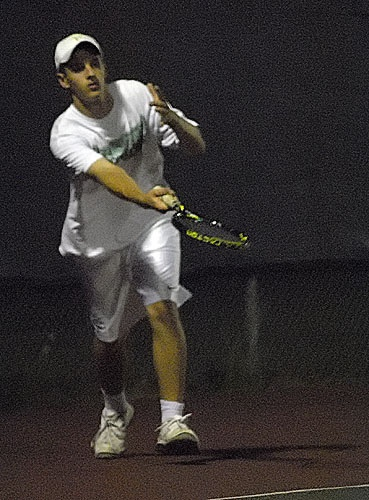Describe the objects in this image and their specific colors. I can see people in black, gray, lightgray, and darkgray tones and tennis racket in black, darkgreen, gray, and olive tones in this image. 